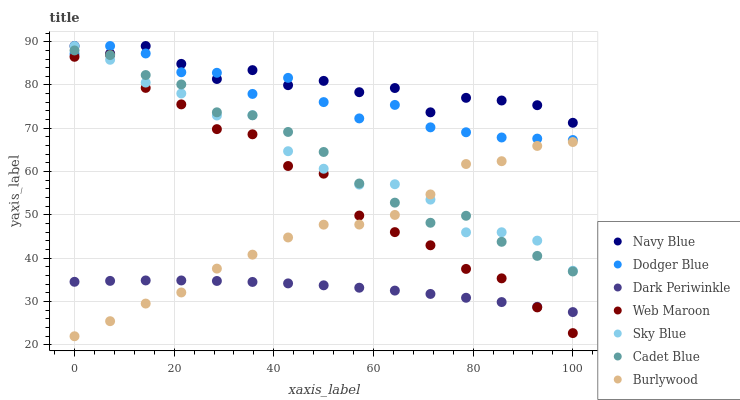Does Dark Periwinkle have the minimum area under the curve?
Answer yes or no. Yes. Does Navy Blue have the maximum area under the curve?
Answer yes or no. Yes. Does Burlywood have the minimum area under the curve?
Answer yes or no. No. Does Burlywood have the maximum area under the curve?
Answer yes or no. No. Is Dark Periwinkle the smoothest?
Answer yes or no. Yes. Is Navy Blue the roughest?
Answer yes or no. Yes. Is Burlywood the smoothest?
Answer yes or no. No. Is Burlywood the roughest?
Answer yes or no. No. Does Burlywood have the lowest value?
Answer yes or no. Yes. Does Navy Blue have the lowest value?
Answer yes or no. No. Does Sky Blue have the highest value?
Answer yes or no. Yes. Does Burlywood have the highest value?
Answer yes or no. No. Is Dark Periwinkle less than Sky Blue?
Answer yes or no. Yes. Is Navy Blue greater than Burlywood?
Answer yes or no. Yes. Does Burlywood intersect Sky Blue?
Answer yes or no. Yes. Is Burlywood less than Sky Blue?
Answer yes or no. No. Is Burlywood greater than Sky Blue?
Answer yes or no. No. Does Dark Periwinkle intersect Sky Blue?
Answer yes or no. No. 